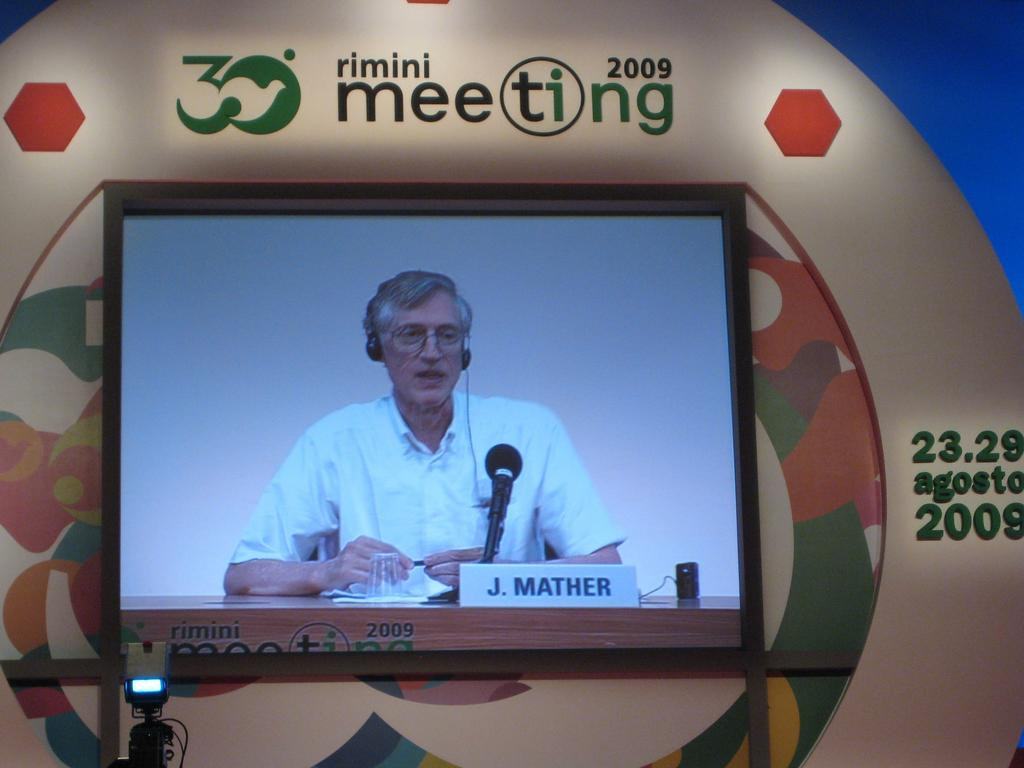<image>
Write a terse but informative summary of the picture. A screen shows a person named J. Mather speaking. 